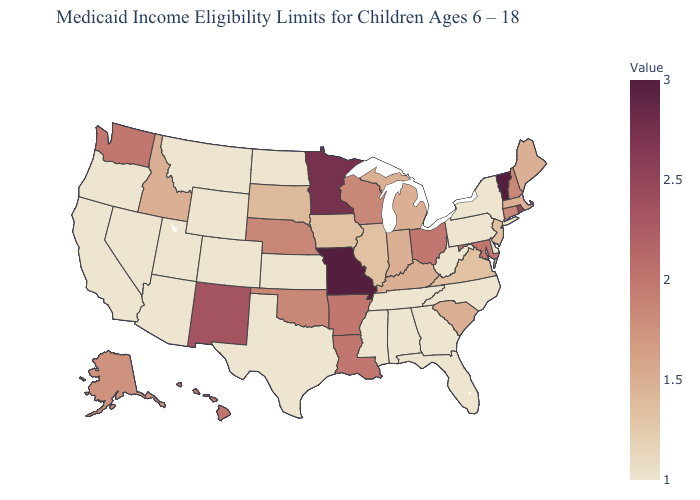Among the states that border Louisiana , which have the lowest value?
Write a very short answer. Mississippi, Texas. Does Maryland have the highest value in the South?
Answer briefly. Yes. Which states have the lowest value in the USA?
Concise answer only. Alabama, Arizona, California, Colorado, Delaware, Florida, Georgia, Kansas, Mississippi, Montana, Nevada, New York, North Carolina, North Dakota, Oregon, Pennsylvania, Tennessee, Texas, Utah, West Virginia, Wyoming. Among the states that border Kentucky , which have the highest value?
Quick response, please. Missouri. 